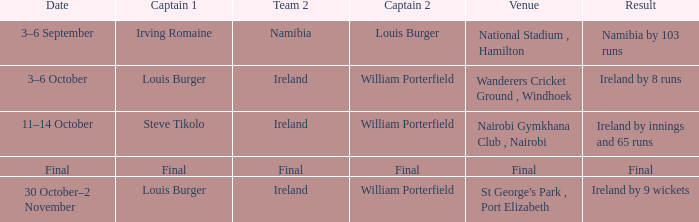Which Captain 2 has a Result of final? Final. 